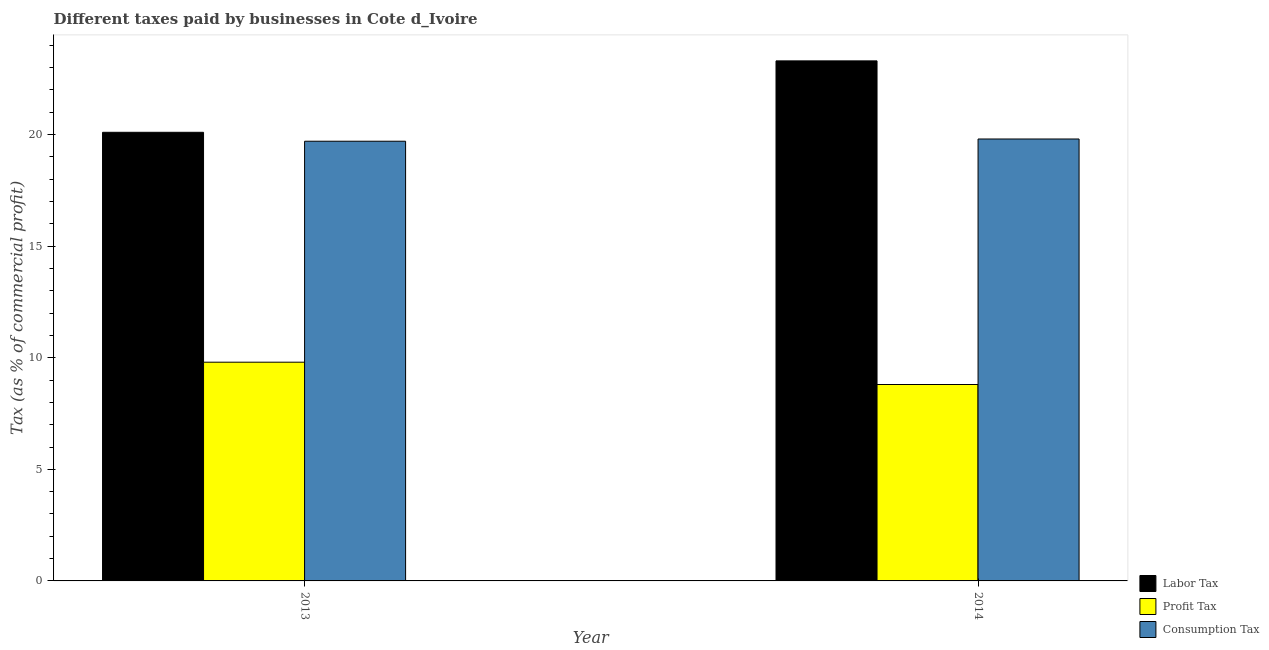How many groups of bars are there?
Give a very brief answer. 2. Are the number of bars on each tick of the X-axis equal?
Make the answer very short. Yes. How many bars are there on the 2nd tick from the left?
Provide a succinct answer. 3. What is the label of the 1st group of bars from the left?
Your response must be concise. 2013. In how many cases, is the number of bars for a given year not equal to the number of legend labels?
Keep it short and to the point. 0. What is the percentage of labor tax in 2014?
Provide a short and direct response. 23.3. Across all years, what is the minimum percentage of profit tax?
Your answer should be compact. 8.8. What is the difference between the percentage of labor tax in 2013 and that in 2014?
Provide a short and direct response. -3.2. What is the average percentage of consumption tax per year?
Give a very brief answer. 19.75. What is the ratio of the percentage of consumption tax in 2013 to that in 2014?
Make the answer very short. 0.99. In how many years, is the percentage of labor tax greater than the average percentage of labor tax taken over all years?
Your answer should be compact. 1. What does the 2nd bar from the left in 2013 represents?
Your answer should be very brief. Profit Tax. What does the 1st bar from the right in 2013 represents?
Give a very brief answer. Consumption Tax. Is it the case that in every year, the sum of the percentage of labor tax and percentage of profit tax is greater than the percentage of consumption tax?
Provide a short and direct response. Yes. How many bars are there?
Offer a terse response. 6. How many years are there in the graph?
Make the answer very short. 2. What is the difference between two consecutive major ticks on the Y-axis?
Your answer should be compact. 5. Does the graph contain grids?
Provide a short and direct response. No. What is the title of the graph?
Provide a succinct answer. Different taxes paid by businesses in Cote d_Ivoire. What is the label or title of the Y-axis?
Keep it short and to the point. Tax (as % of commercial profit). What is the Tax (as % of commercial profit) in Labor Tax in 2013?
Provide a short and direct response. 20.1. What is the Tax (as % of commercial profit) of Labor Tax in 2014?
Give a very brief answer. 23.3. What is the Tax (as % of commercial profit) in Profit Tax in 2014?
Give a very brief answer. 8.8. What is the Tax (as % of commercial profit) of Consumption Tax in 2014?
Your answer should be very brief. 19.8. Across all years, what is the maximum Tax (as % of commercial profit) of Labor Tax?
Give a very brief answer. 23.3. Across all years, what is the maximum Tax (as % of commercial profit) of Profit Tax?
Your answer should be very brief. 9.8. Across all years, what is the maximum Tax (as % of commercial profit) in Consumption Tax?
Provide a short and direct response. 19.8. Across all years, what is the minimum Tax (as % of commercial profit) in Labor Tax?
Your response must be concise. 20.1. Across all years, what is the minimum Tax (as % of commercial profit) in Consumption Tax?
Give a very brief answer. 19.7. What is the total Tax (as % of commercial profit) in Labor Tax in the graph?
Offer a terse response. 43.4. What is the total Tax (as % of commercial profit) in Consumption Tax in the graph?
Your answer should be very brief. 39.5. What is the difference between the Tax (as % of commercial profit) in Labor Tax in 2013 and that in 2014?
Ensure brevity in your answer.  -3.2. What is the difference between the Tax (as % of commercial profit) in Consumption Tax in 2013 and that in 2014?
Provide a succinct answer. -0.1. What is the difference between the Tax (as % of commercial profit) in Labor Tax in 2013 and the Tax (as % of commercial profit) in Profit Tax in 2014?
Your answer should be very brief. 11.3. What is the difference between the Tax (as % of commercial profit) in Labor Tax in 2013 and the Tax (as % of commercial profit) in Consumption Tax in 2014?
Give a very brief answer. 0.3. What is the average Tax (as % of commercial profit) of Labor Tax per year?
Provide a short and direct response. 21.7. What is the average Tax (as % of commercial profit) in Consumption Tax per year?
Offer a very short reply. 19.75. In the year 2013, what is the difference between the Tax (as % of commercial profit) in Profit Tax and Tax (as % of commercial profit) in Consumption Tax?
Offer a terse response. -9.9. In the year 2014, what is the difference between the Tax (as % of commercial profit) of Profit Tax and Tax (as % of commercial profit) of Consumption Tax?
Provide a succinct answer. -11. What is the ratio of the Tax (as % of commercial profit) of Labor Tax in 2013 to that in 2014?
Offer a terse response. 0.86. What is the ratio of the Tax (as % of commercial profit) of Profit Tax in 2013 to that in 2014?
Your response must be concise. 1.11. What is the difference between the highest and the second highest Tax (as % of commercial profit) of Labor Tax?
Your answer should be very brief. 3.2. What is the difference between the highest and the second highest Tax (as % of commercial profit) of Consumption Tax?
Offer a very short reply. 0.1. What is the difference between the highest and the lowest Tax (as % of commercial profit) of Consumption Tax?
Ensure brevity in your answer.  0.1. 